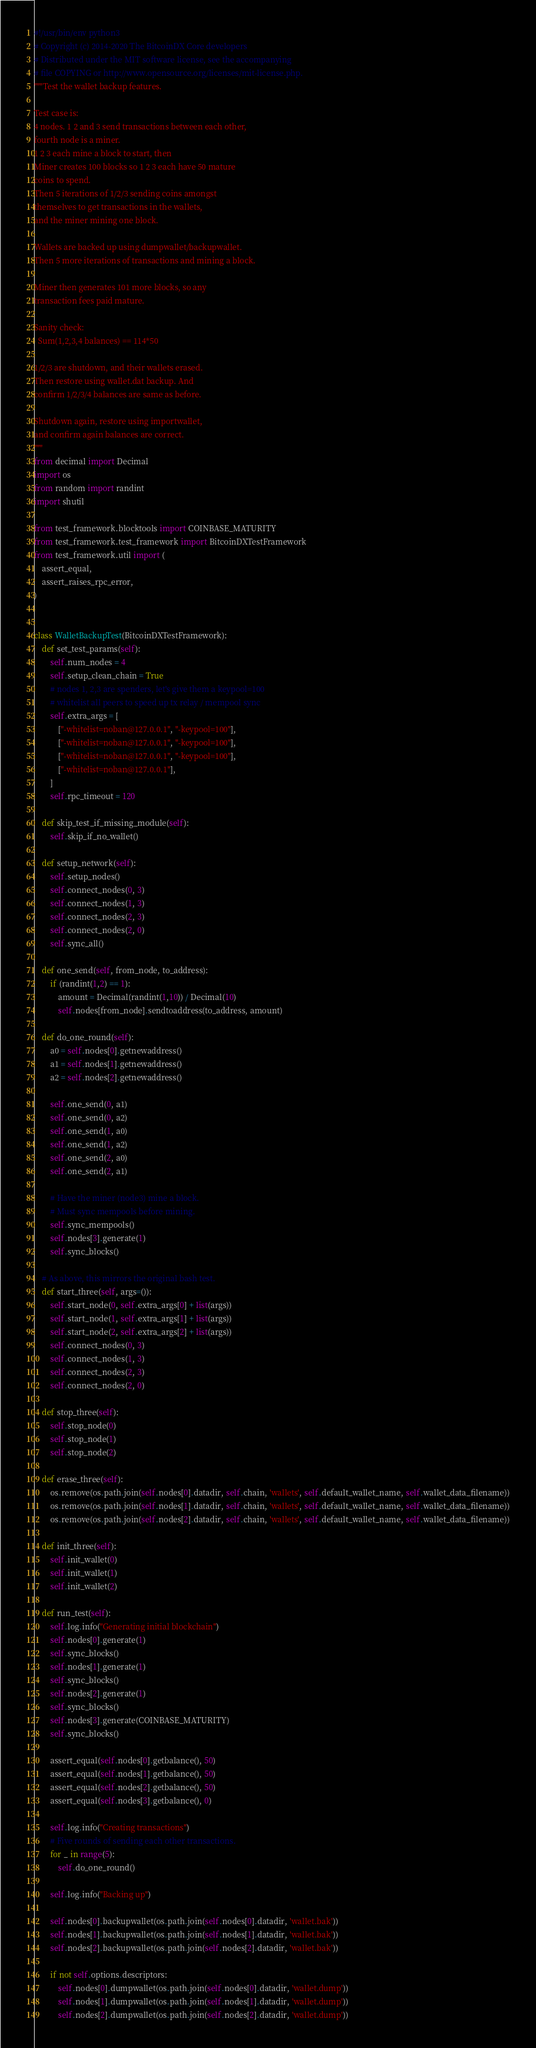Convert code to text. <code><loc_0><loc_0><loc_500><loc_500><_Python_>#!/usr/bin/env python3
# Copyright (c) 2014-2020 The BitcoinDX Core developers
# Distributed under the MIT software license, see the accompanying
# file COPYING or http://www.opensource.org/licenses/mit-license.php.
"""Test the wallet backup features.

Test case is:
4 nodes. 1 2 and 3 send transactions between each other,
fourth node is a miner.
1 2 3 each mine a block to start, then
Miner creates 100 blocks so 1 2 3 each have 50 mature
coins to spend.
Then 5 iterations of 1/2/3 sending coins amongst
themselves to get transactions in the wallets,
and the miner mining one block.

Wallets are backed up using dumpwallet/backupwallet.
Then 5 more iterations of transactions and mining a block.

Miner then generates 101 more blocks, so any
transaction fees paid mature.

Sanity check:
  Sum(1,2,3,4 balances) == 114*50

1/2/3 are shutdown, and their wallets erased.
Then restore using wallet.dat backup. And
confirm 1/2/3/4 balances are same as before.

Shutdown again, restore using importwallet,
and confirm again balances are correct.
"""
from decimal import Decimal
import os
from random import randint
import shutil

from test_framework.blocktools import COINBASE_MATURITY
from test_framework.test_framework import BitcoinDXTestFramework
from test_framework.util import (
    assert_equal,
    assert_raises_rpc_error,
)


class WalletBackupTest(BitcoinDXTestFramework):
    def set_test_params(self):
        self.num_nodes = 4
        self.setup_clean_chain = True
        # nodes 1, 2,3 are spenders, let's give them a keypool=100
        # whitelist all peers to speed up tx relay / mempool sync
        self.extra_args = [
            ["-whitelist=noban@127.0.0.1", "-keypool=100"],
            ["-whitelist=noban@127.0.0.1", "-keypool=100"],
            ["-whitelist=noban@127.0.0.1", "-keypool=100"],
            ["-whitelist=noban@127.0.0.1"],
        ]
        self.rpc_timeout = 120

    def skip_test_if_missing_module(self):
        self.skip_if_no_wallet()

    def setup_network(self):
        self.setup_nodes()
        self.connect_nodes(0, 3)
        self.connect_nodes(1, 3)
        self.connect_nodes(2, 3)
        self.connect_nodes(2, 0)
        self.sync_all()

    def one_send(self, from_node, to_address):
        if (randint(1,2) == 1):
            amount = Decimal(randint(1,10)) / Decimal(10)
            self.nodes[from_node].sendtoaddress(to_address, amount)

    def do_one_round(self):
        a0 = self.nodes[0].getnewaddress()
        a1 = self.nodes[1].getnewaddress()
        a2 = self.nodes[2].getnewaddress()

        self.one_send(0, a1)
        self.one_send(0, a2)
        self.one_send(1, a0)
        self.one_send(1, a2)
        self.one_send(2, a0)
        self.one_send(2, a1)

        # Have the miner (node3) mine a block.
        # Must sync mempools before mining.
        self.sync_mempools()
        self.nodes[3].generate(1)
        self.sync_blocks()

    # As above, this mirrors the original bash test.
    def start_three(self, args=()):
        self.start_node(0, self.extra_args[0] + list(args))
        self.start_node(1, self.extra_args[1] + list(args))
        self.start_node(2, self.extra_args[2] + list(args))
        self.connect_nodes(0, 3)
        self.connect_nodes(1, 3)
        self.connect_nodes(2, 3)
        self.connect_nodes(2, 0)

    def stop_three(self):
        self.stop_node(0)
        self.stop_node(1)
        self.stop_node(2)

    def erase_three(self):
        os.remove(os.path.join(self.nodes[0].datadir, self.chain, 'wallets', self.default_wallet_name, self.wallet_data_filename))
        os.remove(os.path.join(self.nodes[1].datadir, self.chain, 'wallets', self.default_wallet_name, self.wallet_data_filename))
        os.remove(os.path.join(self.nodes[2].datadir, self.chain, 'wallets', self.default_wallet_name, self.wallet_data_filename))

    def init_three(self):
        self.init_wallet(0)
        self.init_wallet(1)
        self.init_wallet(2)

    def run_test(self):
        self.log.info("Generating initial blockchain")
        self.nodes[0].generate(1)
        self.sync_blocks()
        self.nodes[1].generate(1)
        self.sync_blocks()
        self.nodes[2].generate(1)
        self.sync_blocks()
        self.nodes[3].generate(COINBASE_MATURITY)
        self.sync_blocks()

        assert_equal(self.nodes[0].getbalance(), 50)
        assert_equal(self.nodes[1].getbalance(), 50)
        assert_equal(self.nodes[2].getbalance(), 50)
        assert_equal(self.nodes[3].getbalance(), 0)

        self.log.info("Creating transactions")
        # Five rounds of sending each other transactions.
        for _ in range(5):
            self.do_one_round()

        self.log.info("Backing up")

        self.nodes[0].backupwallet(os.path.join(self.nodes[0].datadir, 'wallet.bak'))
        self.nodes[1].backupwallet(os.path.join(self.nodes[1].datadir, 'wallet.bak'))
        self.nodes[2].backupwallet(os.path.join(self.nodes[2].datadir, 'wallet.bak'))

        if not self.options.descriptors:
            self.nodes[0].dumpwallet(os.path.join(self.nodes[0].datadir, 'wallet.dump'))
            self.nodes[1].dumpwallet(os.path.join(self.nodes[1].datadir, 'wallet.dump'))
            self.nodes[2].dumpwallet(os.path.join(self.nodes[2].datadir, 'wallet.dump'))
</code> 